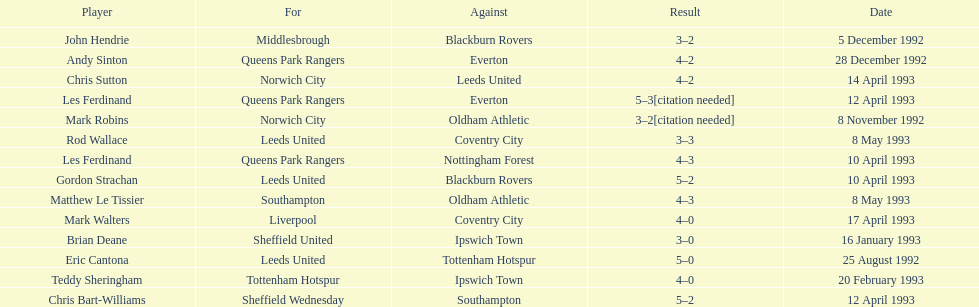Southampton played on may 8th, 1993, who was their opponent? Oldham Athletic. 